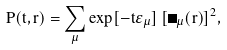Convert formula to latex. <formula><loc_0><loc_0><loc_500><loc_500>P ( t , { r } ) = \sum _ { \mu } \exp [ - t \varepsilon _ { \mu } ] \, [ \Phi _ { \mu } ( { r } ) ] ^ { 2 } ,</formula> 